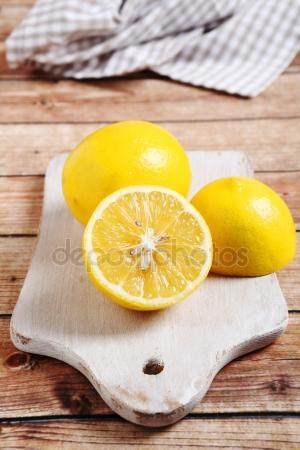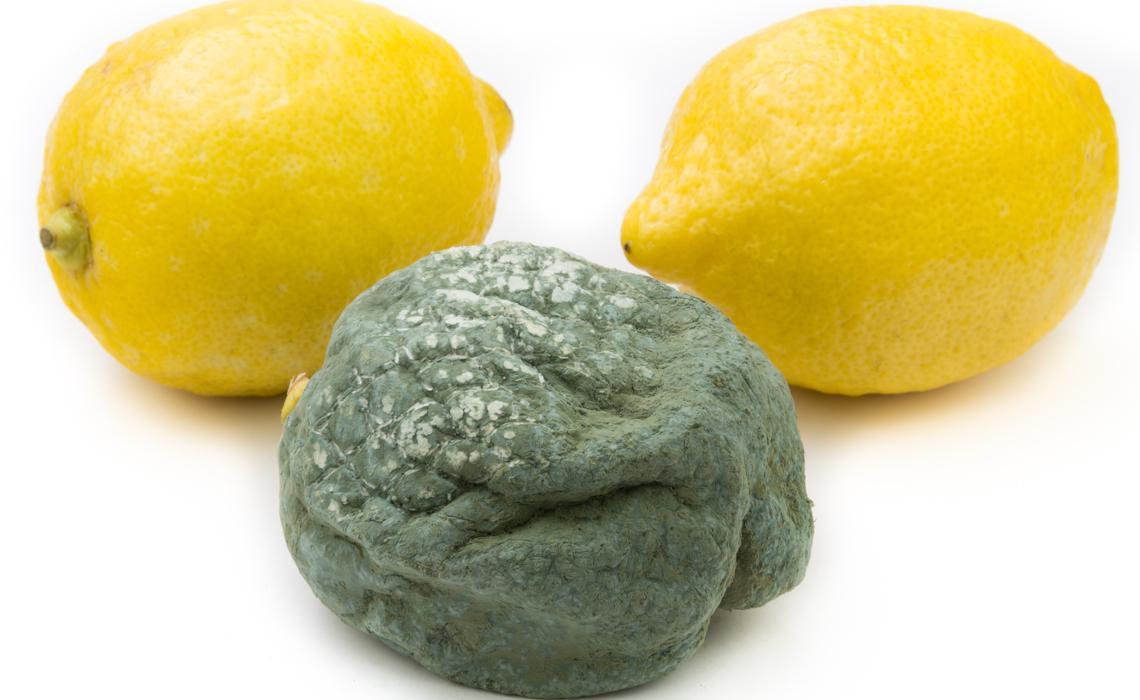The first image is the image on the left, the second image is the image on the right. For the images shown, is this caption "A lemon is on a microplane zester and there is a pile of finely shaved lemon zest." true? Answer yes or no. No. The first image is the image on the left, the second image is the image on the right. Examine the images to the left and right. Is the description "One lemon is cut in half." accurate? Answer yes or no. Yes. 